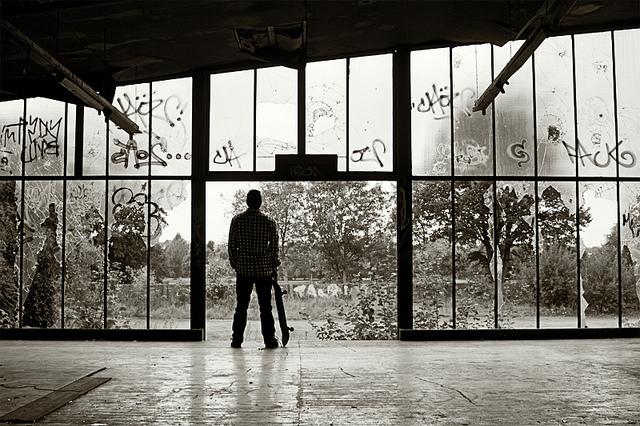Is the room furnished?
Be succinct. No. What is he holding in his right hand?
Keep it brief. Skateboard. Is the man standing still?
Give a very brief answer. Yes. What is the man doing in these images?
Short answer required. Standing. Is there any writing on these windows?
Quick response, please. Yes. 